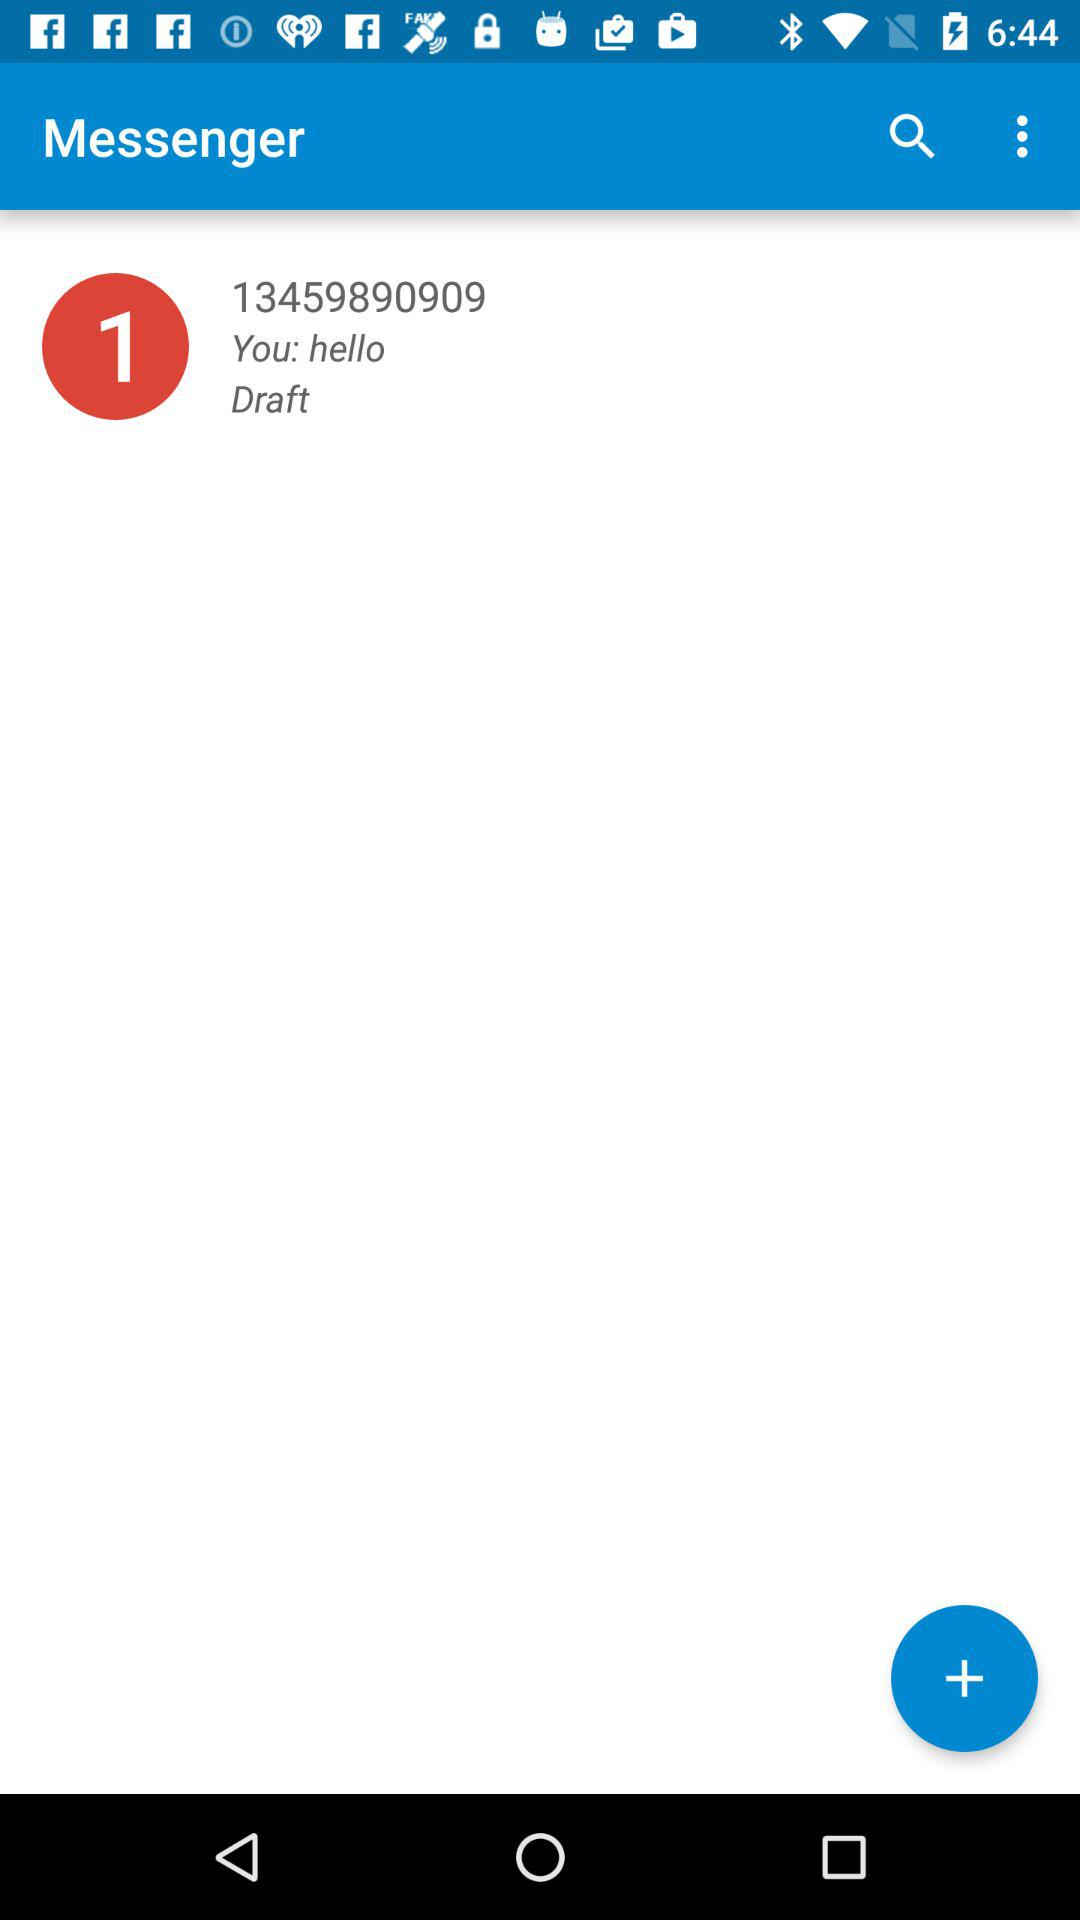What is the message saved in draft? The saved message is "hello". 